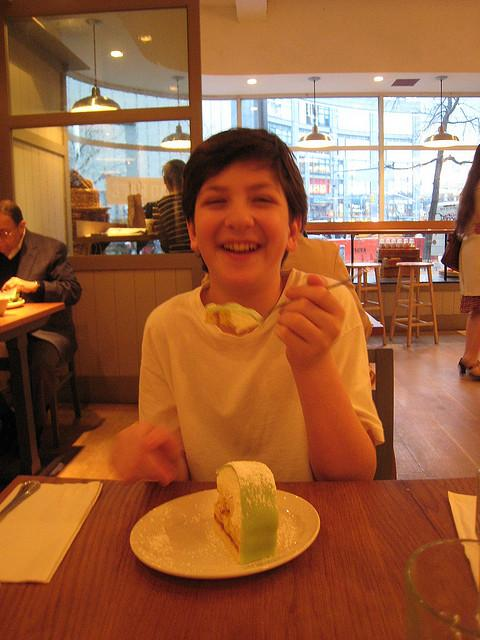What is this cake called?

Choices:
A) princess cake
B) rose cake
C) green cake
D) plum cake princess cake 